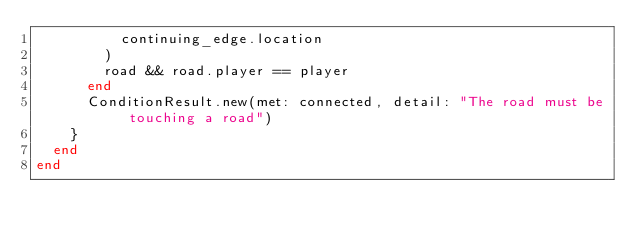Convert code to text. <code><loc_0><loc_0><loc_500><loc_500><_Ruby_>          continuing_edge.location
        )
        road && road.player == player
      end
      ConditionResult.new(met: connected, detail: "The road must be touching a road")
    }
  end
end
</code> 